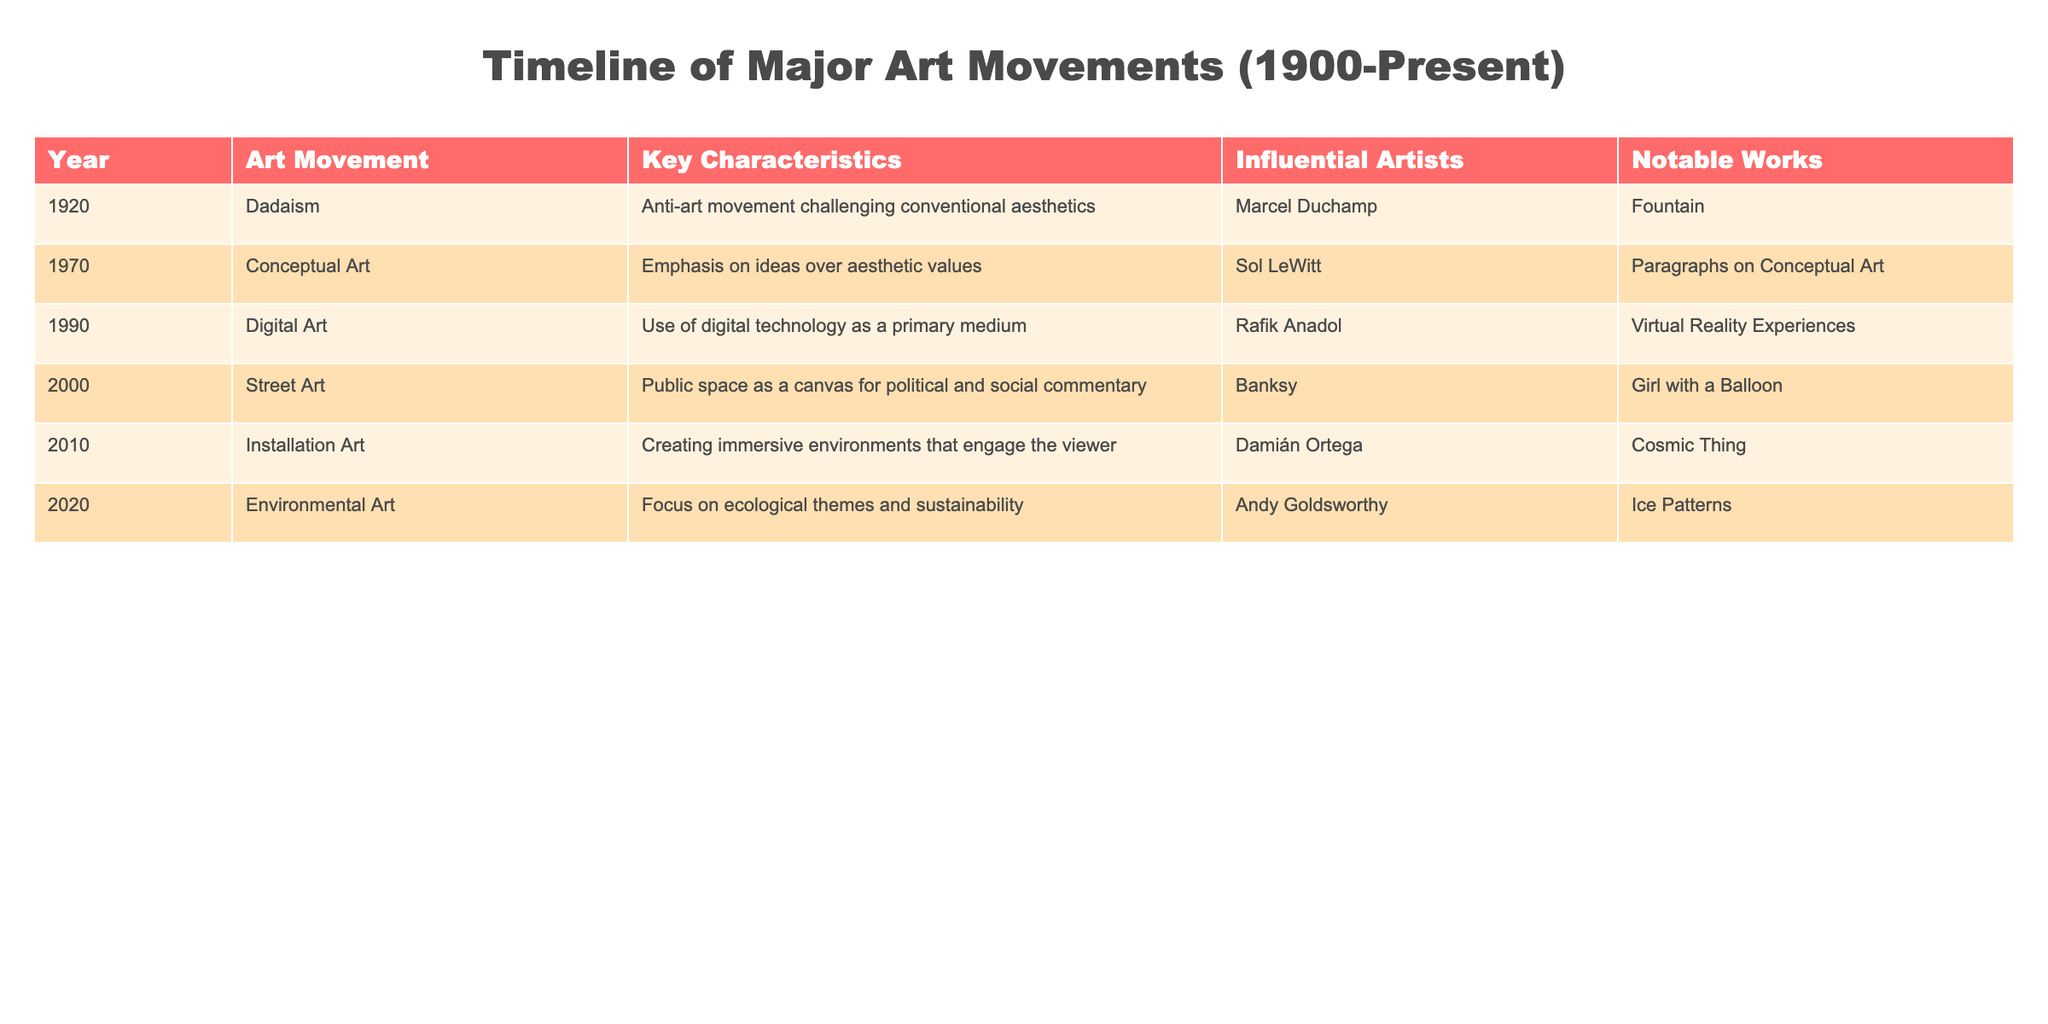What is the last art movement listed in the table? The table lists art movements in chronological order, starting from 1920 to 2020. The last entry corresponds to the year 2020, which is the art movement "Environmental Art."
Answer: Environmental Art Which artist is associated with Dadaism? The table indicates that Marcel Duchamp is the influential artist related to Dadaism, which is noted in the year 1920.
Answer: Marcel Duchamp How many art movements are listed in the table? By counting each row in the table, there are six distinct art movements detailed from 1920 to 2020.
Answer: 6 Is "Conceptual Art" an art movement that emphasizes aesthetic values? The characteristics of Conceptual Art, as stated in the table, highlight an emphasis on ideas over aesthetic values, making this statement false.
Answer: No Which art movement was influential in the 1990s, and what was its notable work? Referring to the entry for the year 1990, "Digital Art" is the movement listed, and the notable work associated with it is "Virtual Reality Experiences."
Answer: Digital Art, Virtual Reality Experiences What is the difference between the years of Street Art and Environmental Art? The table shows that Street Art is from the year 2000 and Environmental Art is from 2020. The difference between these two years is 20 years.
Answer: 20 years Which influential artist is associated with both Installation Art and Digital Art? By examining the table carefully, it shows that Damián Ortega is associated with Installation Art in 2010, but there is no overlap with Digital Art in 1990; hence, there is no artist associated with both movements.
Answer: None What is the average year of the listed art movements? To find the average, we sum the years (1920 + 1970 + 1990 + 2000 + 2010 + 2020 = 12010) and divide by the number of movements (6). Thus, the average year is 12010/6, which equals 2001.67, approximately 2002 when rounded.
Answer: 2002 Which movement focuses on ecological themes and sustainability? The entry for the year 2020 states that Environmental Art focuses on ecological themes and sustainability, making this a direct identification from the table.
Answer: Environmental Art 